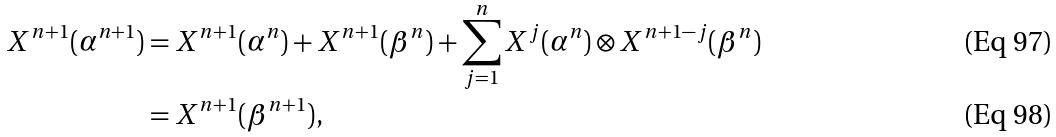<formula> <loc_0><loc_0><loc_500><loc_500>X ^ { n + 1 } ( \alpha ^ { n + 1 } ) & = X ^ { n + 1 } ( \alpha ^ { n } ) + X ^ { n + 1 } ( \beta ^ { n } ) + \sum _ { j = 1 } ^ { n } X ^ { j } ( \alpha ^ { n } ) \otimes X ^ { n + 1 - j } ( \beta ^ { n } ) \\ & = X ^ { n + 1 } ( \beta ^ { n + 1 } ) ,</formula> 